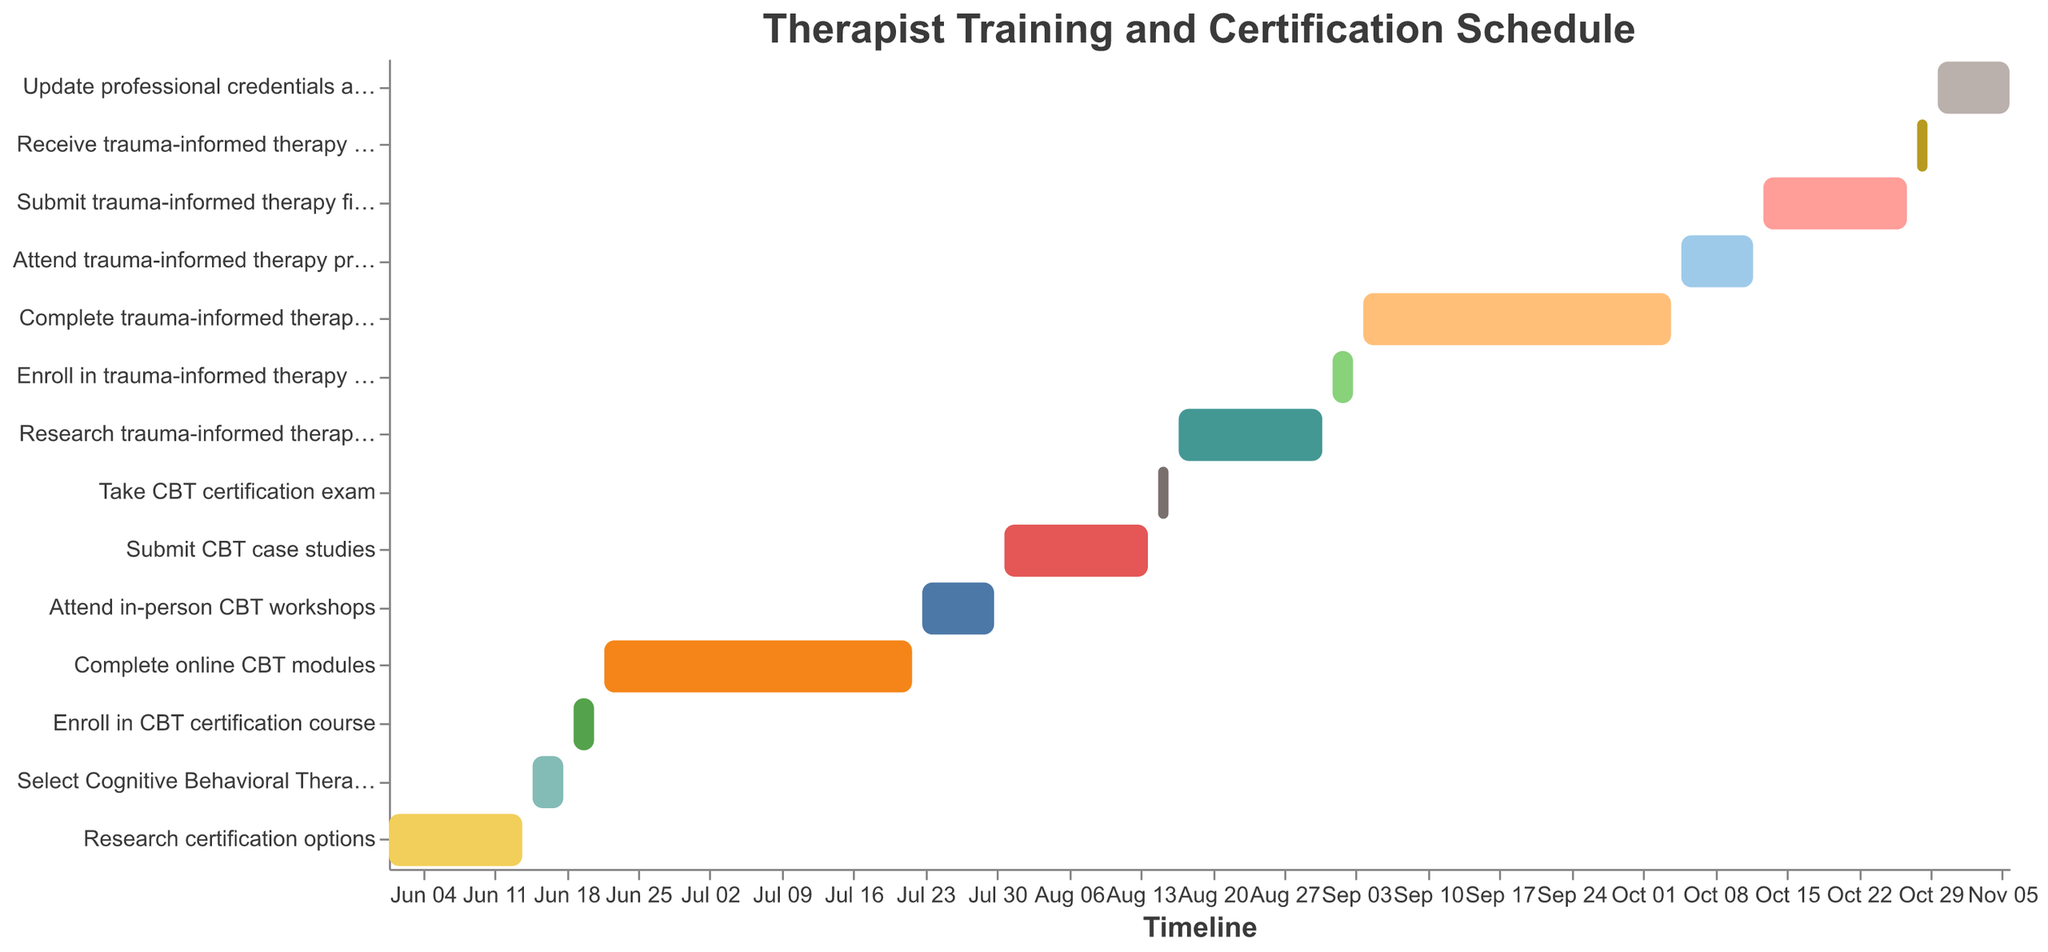What's the title of the Gantt Chart? The title is shown at the top of the chart. You can identify it directly by reading the text in the title section.
Answer: Therapist Training and Certification Schedule How many tasks are displayed in the chart? You can count the number of unique tasks listed on the y-axis of the chart.
Answer: 14 What is the duration of the 'Complete online CBT modules' task? Subtract the start date from the end date of the task 'Complete online CBT modules'. Start Date: June 22, End Date: July 22. The duration is calculated as 22 July - 22 June = 30 days
Answer: 30 days Which task directly follows 'Take CBT certification exam'? Look at the sequence of tasks and identify the task that starts immediately after 'Take CBT certification exam' ends on August 16. The next task is 'Research trauma-informed therapy training', which starts on August 17.
Answer: Research trauma-informed therapy training Compare the duration of 'Attend in-person CBT workshops' and 'Attend trauma-informed therapy practicum'. Which one is longer? Calculate the duration of each task. 'Attend in-person CBT workshops': July 23 - July 30 = 8 days. 'Attend trauma-informed therapy practicum': October 5 - October 12 = 8 days. Both tasks have the same duration.
Answer: They are equal What tasks are scheduled in September? Observe the timeline and identify all tasks with start dates or end dates falling in September. They are 'Enroll in trauma-informed therapy course' and 'Complete trauma-informed therapy online modules'.
Answer: Enroll in trauma-informed therapy course, Complete trauma-informed therapy online modules When does the 'Update professional credentials and marketing materials' task start and end? Refer to the task 'Update professional credentials and marketing materials' on the chart and note the start and end dates. Start Date: October 30, End Date: November 6.
Answer: October 30 - November 6 What is the first task to be completed in August? Identify tasks that end in August and find the one with the earliest end date. Task: 'Submit CBT case studies' ends on August 14.
Answer: Submit CBT case studies Calculate the total duration from 'Research certification options' to 'Update professional credentials and marketing materials'. Find the start date of 'Research certification options' (June 1) and the end date of 'Update professional credentials and marketing materials' (November 6). Calculate the difference in days. Total duration = November 6 - June 1 = 159 days
Answer: 159 days How does the chart help in scheduling and time management for therapist training? The chart visually organizes tasks over time, helping to plan, track progress, and ensure timely completion of training and certification steps. It allows for easy identification of task dependencies and critical timelines.
Answer: It provides a clear visual schedule for planning and tracking 